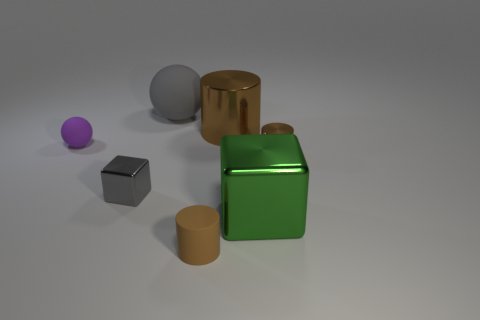Is the material of the sphere that is right of the purple matte sphere the same as the tiny brown cylinder in front of the large green shiny block?
Your response must be concise. Yes. What number of other objects are there of the same color as the tiny matte ball?
Provide a short and direct response. 0. What number of things are either things in front of the small gray cube or things left of the big gray thing?
Offer a very short reply. 4. There is a shiny block on the right side of the object that is behind the big shiny cylinder; what size is it?
Your answer should be compact. Large. What size is the green cube?
Keep it short and to the point. Large. There is a tiny metal thing that is to the left of the large sphere; does it have the same color as the rubber thing in front of the purple matte sphere?
Give a very brief answer. No. What number of other objects are there of the same material as the big brown thing?
Your answer should be compact. 3. Is there a small yellow rubber cube?
Provide a succinct answer. No. Is the material of the ball on the left side of the big rubber thing the same as the green cube?
Keep it short and to the point. No. There is another small thing that is the same shape as the brown matte object; what is its material?
Offer a very short reply. Metal. 